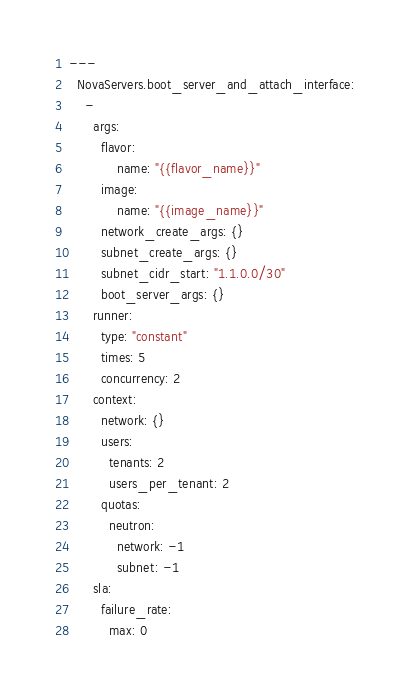<code> <loc_0><loc_0><loc_500><loc_500><_YAML_>---
  NovaServers.boot_server_and_attach_interface:
    -
      args:
        flavor:
            name: "{{flavor_name}}"
        image:
            name: "{{image_name}}"
        network_create_args: {}
        subnet_create_args: {}
        subnet_cidr_start: "1.1.0.0/30"
        boot_server_args: {}
      runner:
        type: "constant"
        times: 5
        concurrency: 2
      context:
        network: {}
        users:
          tenants: 2
          users_per_tenant: 2
        quotas:
          neutron:
            network: -1
            subnet: -1
      sla:
        failure_rate:
          max: 0
</code> 